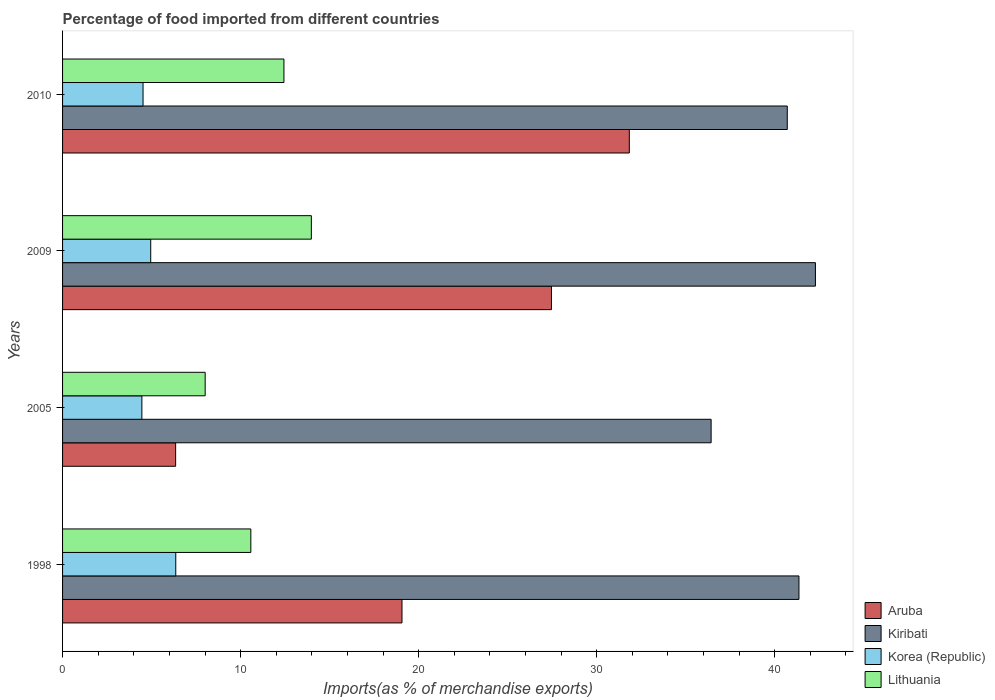How many groups of bars are there?
Keep it short and to the point. 4. Are the number of bars on each tick of the Y-axis equal?
Your response must be concise. Yes. How many bars are there on the 2nd tick from the bottom?
Provide a succinct answer. 4. What is the percentage of imports to different countries in Aruba in 2009?
Ensure brevity in your answer.  27.46. Across all years, what is the maximum percentage of imports to different countries in Aruba?
Ensure brevity in your answer.  31.83. Across all years, what is the minimum percentage of imports to different countries in Aruba?
Provide a short and direct response. 6.35. In which year was the percentage of imports to different countries in Kiribati maximum?
Your answer should be very brief. 2009. What is the total percentage of imports to different countries in Korea (Republic) in the graph?
Your answer should be compact. 20.28. What is the difference between the percentage of imports to different countries in Aruba in 2005 and that in 2010?
Give a very brief answer. -25.48. What is the difference between the percentage of imports to different countries in Lithuania in 2010 and the percentage of imports to different countries in Aruba in 1998?
Offer a terse response. -6.63. What is the average percentage of imports to different countries in Aruba per year?
Your answer should be very brief. 21.18. In the year 2009, what is the difference between the percentage of imports to different countries in Aruba and percentage of imports to different countries in Kiribati?
Your response must be concise. -14.83. In how many years, is the percentage of imports to different countries in Aruba greater than 22 %?
Make the answer very short. 2. What is the ratio of the percentage of imports to different countries in Korea (Republic) in 1998 to that in 2010?
Offer a terse response. 1.41. Is the difference between the percentage of imports to different countries in Aruba in 2005 and 2009 greater than the difference between the percentage of imports to different countries in Kiribati in 2005 and 2009?
Your response must be concise. No. What is the difference between the highest and the second highest percentage of imports to different countries in Korea (Republic)?
Your answer should be very brief. 1.41. What is the difference between the highest and the lowest percentage of imports to different countries in Lithuania?
Provide a succinct answer. 5.96. Is it the case that in every year, the sum of the percentage of imports to different countries in Lithuania and percentage of imports to different countries in Kiribati is greater than the sum of percentage of imports to different countries in Korea (Republic) and percentage of imports to different countries in Aruba?
Give a very brief answer. No. What does the 1st bar from the top in 2010 represents?
Provide a succinct answer. Lithuania. Is it the case that in every year, the sum of the percentage of imports to different countries in Lithuania and percentage of imports to different countries in Korea (Republic) is greater than the percentage of imports to different countries in Aruba?
Make the answer very short. No. Are all the bars in the graph horizontal?
Offer a very short reply. Yes. What is the difference between two consecutive major ticks on the X-axis?
Give a very brief answer. 10. Are the values on the major ticks of X-axis written in scientific E-notation?
Your answer should be very brief. No. What is the title of the graph?
Your response must be concise. Percentage of food imported from different countries. What is the label or title of the X-axis?
Give a very brief answer. Imports(as % of merchandise exports). What is the label or title of the Y-axis?
Your answer should be compact. Years. What is the Imports(as % of merchandise exports) in Aruba in 1998?
Offer a terse response. 19.06. What is the Imports(as % of merchandise exports) in Kiribati in 1998?
Ensure brevity in your answer.  41.36. What is the Imports(as % of merchandise exports) of Korea (Republic) in 1998?
Provide a short and direct response. 6.36. What is the Imports(as % of merchandise exports) of Lithuania in 1998?
Offer a very short reply. 10.57. What is the Imports(as % of merchandise exports) of Aruba in 2005?
Your response must be concise. 6.35. What is the Imports(as % of merchandise exports) in Kiribati in 2005?
Your response must be concise. 36.43. What is the Imports(as % of merchandise exports) of Korea (Republic) in 2005?
Keep it short and to the point. 4.45. What is the Imports(as % of merchandise exports) of Lithuania in 2005?
Give a very brief answer. 8.01. What is the Imports(as % of merchandise exports) of Aruba in 2009?
Your response must be concise. 27.46. What is the Imports(as % of merchandise exports) in Kiribati in 2009?
Keep it short and to the point. 42.29. What is the Imports(as % of merchandise exports) in Korea (Republic) in 2009?
Provide a short and direct response. 4.95. What is the Imports(as % of merchandise exports) in Lithuania in 2009?
Offer a terse response. 13.97. What is the Imports(as % of merchandise exports) in Aruba in 2010?
Ensure brevity in your answer.  31.83. What is the Imports(as % of merchandise exports) of Kiribati in 2010?
Your response must be concise. 40.7. What is the Imports(as % of merchandise exports) of Korea (Republic) in 2010?
Your answer should be compact. 4.52. What is the Imports(as % of merchandise exports) in Lithuania in 2010?
Make the answer very short. 12.43. Across all years, what is the maximum Imports(as % of merchandise exports) in Aruba?
Offer a very short reply. 31.83. Across all years, what is the maximum Imports(as % of merchandise exports) of Kiribati?
Keep it short and to the point. 42.29. Across all years, what is the maximum Imports(as % of merchandise exports) of Korea (Republic)?
Offer a terse response. 6.36. Across all years, what is the maximum Imports(as % of merchandise exports) in Lithuania?
Offer a terse response. 13.97. Across all years, what is the minimum Imports(as % of merchandise exports) of Aruba?
Provide a short and direct response. 6.35. Across all years, what is the minimum Imports(as % of merchandise exports) of Kiribati?
Your answer should be compact. 36.43. Across all years, what is the minimum Imports(as % of merchandise exports) in Korea (Republic)?
Ensure brevity in your answer.  4.45. Across all years, what is the minimum Imports(as % of merchandise exports) of Lithuania?
Give a very brief answer. 8.01. What is the total Imports(as % of merchandise exports) in Aruba in the graph?
Ensure brevity in your answer.  84.71. What is the total Imports(as % of merchandise exports) of Kiribati in the graph?
Make the answer very short. 160.78. What is the total Imports(as % of merchandise exports) of Korea (Republic) in the graph?
Your response must be concise. 20.28. What is the total Imports(as % of merchandise exports) in Lithuania in the graph?
Provide a succinct answer. 44.99. What is the difference between the Imports(as % of merchandise exports) of Aruba in 1998 and that in 2005?
Offer a very short reply. 12.71. What is the difference between the Imports(as % of merchandise exports) in Kiribati in 1998 and that in 2005?
Give a very brief answer. 4.93. What is the difference between the Imports(as % of merchandise exports) in Korea (Republic) in 1998 and that in 2005?
Offer a very short reply. 1.9. What is the difference between the Imports(as % of merchandise exports) of Lithuania in 1998 and that in 2005?
Your answer should be compact. 2.56. What is the difference between the Imports(as % of merchandise exports) in Aruba in 1998 and that in 2009?
Make the answer very short. -8.4. What is the difference between the Imports(as % of merchandise exports) in Kiribati in 1998 and that in 2009?
Ensure brevity in your answer.  -0.93. What is the difference between the Imports(as % of merchandise exports) in Korea (Republic) in 1998 and that in 2009?
Your answer should be very brief. 1.41. What is the difference between the Imports(as % of merchandise exports) in Lithuania in 1998 and that in 2009?
Ensure brevity in your answer.  -3.4. What is the difference between the Imports(as % of merchandise exports) in Aruba in 1998 and that in 2010?
Keep it short and to the point. -12.77. What is the difference between the Imports(as % of merchandise exports) in Kiribati in 1998 and that in 2010?
Provide a short and direct response. 0.66. What is the difference between the Imports(as % of merchandise exports) in Korea (Republic) in 1998 and that in 2010?
Your answer should be compact. 1.84. What is the difference between the Imports(as % of merchandise exports) in Lithuania in 1998 and that in 2010?
Give a very brief answer. -1.86. What is the difference between the Imports(as % of merchandise exports) of Aruba in 2005 and that in 2009?
Keep it short and to the point. -21.11. What is the difference between the Imports(as % of merchandise exports) in Kiribati in 2005 and that in 2009?
Give a very brief answer. -5.86. What is the difference between the Imports(as % of merchandise exports) in Korea (Republic) in 2005 and that in 2009?
Offer a very short reply. -0.5. What is the difference between the Imports(as % of merchandise exports) of Lithuania in 2005 and that in 2009?
Give a very brief answer. -5.96. What is the difference between the Imports(as % of merchandise exports) in Aruba in 2005 and that in 2010?
Give a very brief answer. -25.48. What is the difference between the Imports(as % of merchandise exports) in Kiribati in 2005 and that in 2010?
Offer a terse response. -4.28. What is the difference between the Imports(as % of merchandise exports) in Korea (Republic) in 2005 and that in 2010?
Give a very brief answer. -0.07. What is the difference between the Imports(as % of merchandise exports) in Lithuania in 2005 and that in 2010?
Your response must be concise. -4.42. What is the difference between the Imports(as % of merchandise exports) in Aruba in 2009 and that in 2010?
Give a very brief answer. -4.37. What is the difference between the Imports(as % of merchandise exports) of Kiribati in 2009 and that in 2010?
Give a very brief answer. 1.58. What is the difference between the Imports(as % of merchandise exports) in Korea (Republic) in 2009 and that in 2010?
Give a very brief answer. 0.43. What is the difference between the Imports(as % of merchandise exports) in Lithuania in 2009 and that in 2010?
Offer a terse response. 1.54. What is the difference between the Imports(as % of merchandise exports) in Aruba in 1998 and the Imports(as % of merchandise exports) in Kiribati in 2005?
Ensure brevity in your answer.  -17.36. What is the difference between the Imports(as % of merchandise exports) of Aruba in 1998 and the Imports(as % of merchandise exports) of Korea (Republic) in 2005?
Your answer should be compact. 14.61. What is the difference between the Imports(as % of merchandise exports) of Aruba in 1998 and the Imports(as % of merchandise exports) of Lithuania in 2005?
Ensure brevity in your answer.  11.05. What is the difference between the Imports(as % of merchandise exports) of Kiribati in 1998 and the Imports(as % of merchandise exports) of Korea (Republic) in 2005?
Provide a succinct answer. 36.91. What is the difference between the Imports(as % of merchandise exports) of Kiribati in 1998 and the Imports(as % of merchandise exports) of Lithuania in 2005?
Your answer should be compact. 33.35. What is the difference between the Imports(as % of merchandise exports) of Korea (Republic) in 1998 and the Imports(as % of merchandise exports) of Lithuania in 2005?
Give a very brief answer. -1.65. What is the difference between the Imports(as % of merchandise exports) of Aruba in 1998 and the Imports(as % of merchandise exports) of Kiribati in 2009?
Provide a succinct answer. -23.22. What is the difference between the Imports(as % of merchandise exports) in Aruba in 1998 and the Imports(as % of merchandise exports) in Korea (Republic) in 2009?
Keep it short and to the point. 14.11. What is the difference between the Imports(as % of merchandise exports) of Aruba in 1998 and the Imports(as % of merchandise exports) of Lithuania in 2009?
Keep it short and to the point. 5.09. What is the difference between the Imports(as % of merchandise exports) in Kiribati in 1998 and the Imports(as % of merchandise exports) in Korea (Republic) in 2009?
Offer a very short reply. 36.41. What is the difference between the Imports(as % of merchandise exports) of Kiribati in 1998 and the Imports(as % of merchandise exports) of Lithuania in 2009?
Provide a short and direct response. 27.39. What is the difference between the Imports(as % of merchandise exports) of Korea (Republic) in 1998 and the Imports(as % of merchandise exports) of Lithuania in 2009?
Provide a short and direct response. -7.62. What is the difference between the Imports(as % of merchandise exports) in Aruba in 1998 and the Imports(as % of merchandise exports) in Kiribati in 2010?
Your response must be concise. -21.64. What is the difference between the Imports(as % of merchandise exports) in Aruba in 1998 and the Imports(as % of merchandise exports) in Korea (Republic) in 2010?
Offer a very short reply. 14.54. What is the difference between the Imports(as % of merchandise exports) in Aruba in 1998 and the Imports(as % of merchandise exports) in Lithuania in 2010?
Your response must be concise. 6.63. What is the difference between the Imports(as % of merchandise exports) of Kiribati in 1998 and the Imports(as % of merchandise exports) of Korea (Republic) in 2010?
Provide a short and direct response. 36.84. What is the difference between the Imports(as % of merchandise exports) of Kiribati in 1998 and the Imports(as % of merchandise exports) of Lithuania in 2010?
Provide a succinct answer. 28.93. What is the difference between the Imports(as % of merchandise exports) in Korea (Republic) in 1998 and the Imports(as % of merchandise exports) in Lithuania in 2010?
Keep it short and to the point. -6.08. What is the difference between the Imports(as % of merchandise exports) of Aruba in 2005 and the Imports(as % of merchandise exports) of Kiribati in 2009?
Your answer should be compact. -35.94. What is the difference between the Imports(as % of merchandise exports) in Aruba in 2005 and the Imports(as % of merchandise exports) in Korea (Republic) in 2009?
Give a very brief answer. 1.4. What is the difference between the Imports(as % of merchandise exports) of Aruba in 2005 and the Imports(as % of merchandise exports) of Lithuania in 2009?
Your response must be concise. -7.62. What is the difference between the Imports(as % of merchandise exports) in Kiribati in 2005 and the Imports(as % of merchandise exports) in Korea (Republic) in 2009?
Keep it short and to the point. 31.48. What is the difference between the Imports(as % of merchandise exports) in Kiribati in 2005 and the Imports(as % of merchandise exports) in Lithuania in 2009?
Your answer should be compact. 22.45. What is the difference between the Imports(as % of merchandise exports) in Korea (Republic) in 2005 and the Imports(as % of merchandise exports) in Lithuania in 2009?
Your response must be concise. -9.52. What is the difference between the Imports(as % of merchandise exports) in Aruba in 2005 and the Imports(as % of merchandise exports) in Kiribati in 2010?
Keep it short and to the point. -34.35. What is the difference between the Imports(as % of merchandise exports) of Aruba in 2005 and the Imports(as % of merchandise exports) of Korea (Republic) in 2010?
Your response must be concise. 1.83. What is the difference between the Imports(as % of merchandise exports) in Aruba in 2005 and the Imports(as % of merchandise exports) in Lithuania in 2010?
Offer a terse response. -6.08. What is the difference between the Imports(as % of merchandise exports) in Kiribati in 2005 and the Imports(as % of merchandise exports) in Korea (Republic) in 2010?
Your response must be concise. 31.91. What is the difference between the Imports(as % of merchandise exports) of Kiribati in 2005 and the Imports(as % of merchandise exports) of Lithuania in 2010?
Your response must be concise. 23.99. What is the difference between the Imports(as % of merchandise exports) of Korea (Republic) in 2005 and the Imports(as % of merchandise exports) of Lithuania in 2010?
Provide a short and direct response. -7.98. What is the difference between the Imports(as % of merchandise exports) in Aruba in 2009 and the Imports(as % of merchandise exports) in Kiribati in 2010?
Provide a short and direct response. -13.25. What is the difference between the Imports(as % of merchandise exports) of Aruba in 2009 and the Imports(as % of merchandise exports) of Korea (Republic) in 2010?
Your answer should be very brief. 22.94. What is the difference between the Imports(as % of merchandise exports) of Aruba in 2009 and the Imports(as % of merchandise exports) of Lithuania in 2010?
Offer a terse response. 15.03. What is the difference between the Imports(as % of merchandise exports) of Kiribati in 2009 and the Imports(as % of merchandise exports) of Korea (Republic) in 2010?
Make the answer very short. 37.77. What is the difference between the Imports(as % of merchandise exports) of Kiribati in 2009 and the Imports(as % of merchandise exports) of Lithuania in 2010?
Your response must be concise. 29.85. What is the difference between the Imports(as % of merchandise exports) in Korea (Republic) in 2009 and the Imports(as % of merchandise exports) in Lithuania in 2010?
Provide a short and direct response. -7.48. What is the average Imports(as % of merchandise exports) of Aruba per year?
Ensure brevity in your answer.  21.18. What is the average Imports(as % of merchandise exports) in Kiribati per year?
Ensure brevity in your answer.  40.19. What is the average Imports(as % of merchandise exports) of Korea (Republic) per year?
Your answer should be very brief. 5.07. What is the average Imports(as % of merchandise exports) of Lithuania per year?
Give a very brief answer. 11.25. In the year 1998, what is the difference between the Imports(as % of merchandise exports) in Aruba and Imports(as % of merchandise exports) in Kiribati?
Give a very brief answer. -22.3. In the year 1998, what is the difference between the Imports(as % of merchandise exports) in Aruba and Imports(as % of merchandise exports) in Korea (Republic)?
Ensure brevity in your answer.  12.71. In the year 1998, what is the difference between the Imports(as % of merchandise exports) in Aruba and Imports(as % of merchandise exports) in Lithuania?
Provide a short and direct response. 8.49. In the year 1998, what is the difference between the Imports(as % of merchandise exports) of Kiribati and Imports(as % of merchandise exports) of Korea (Republic)?
Make the answer very short. 35. In the year 1998, what is the difference between the Imports(as % of merchandise exports) of Kiribati and Imports(as % of merchandise exports) of Lithuania?
Provide a short and direct response. 30.79. In the year 1998, what is the difference between the Imports(as % of merchandise exports) in Korea (Republic) and Imports(as % of merchandise exports) in Lithuania?
Give a very brief answer. -4.22. In the year 2005, what is the difference between the Imports(as % of merchandise exports) of Aruba and Imports(as % of merchandise exports) of Kiribati?
Offer a terse response. -30.08. In the year 2005, what is the difference between the Imports(as % of merchandise exports) of Aruba and Imports(as % of merchandise exports) of Korea (Republic)?
Keep it short and to the point. 1.9. In the year 2005, what is the difference between the Imports(as % of merchandise exports) in Aruba and Imports(as % of merchandise exports) in Lithuania?
Ensure brevity in your answer.  -1.66. In the year 2005, what is the difference between the Imports(as % of merchandise exports) in Kiribati and Imports(as % of merchandise exports) in Korea (Republic)?
Offer a very short reply. 31.97. In the year 2005, what is the difference between the Imports(as % of merchandise exports) in Kiribati and Imports(as % of merchandise exports) in Lithuania?
Give a very brief answer. 28.42. In the year 2005, what is the difference between the Imports(as % of merchandise exports) in Korea (Republic) and Imports(as % of merchandise exports) in Lithuania?
Your answer should be compact. -3.56. In the year 2009, what is the difference between the Imports(as % of merchandise exports) in Aruba and Imports(as % of merchandise exports) in Kiribati?
Your answer should be compact. -14.83. In the year 2009, what is the difference between the Imports(as % of merchandise exports) of Aruba and Imports(as % of merchandise exports) of Korea (Republic)?
Offer a very short reply. 22.51. In the year 2009, what is the difference between the Imports(as % of merchandise exports) of Aruba and Imports(as % of merchandise exports) of Lithuania?
Offer a terse response. 13.49. In the year 2009, what is the difference between the Imports(as % of merchandise exports) in Kiribati and Imports(as % of merchandise exports) in Korea (Republic)?
Your response must be concise. 37.34. In the year 2009, what is the difference between the Imports(as % of merchandise exports) of Kiribati and Imports(as % of merchandise exports) of Lithuania?
Your response must be concise. 28.31. In the year 2009, what is the difference between the Imports(as % of merchandise exports) of Korea (Republic) and Imports(as % of merchandise exports) of Lithuania?
Offer a very short reply. -9.02. In the year 2010, what is the difference between the Imports(as % of merchandise exports) of Aruba and Imports(as % of merchandise exports) of Kiribati?
Make the answer very short. -8.87. In the year 2010, what is the difference between the Imports(as % of merchandise exports) of Aruba and Imports(as % of merchandise exports) of Korea (Republic)?
Offer a terse response. 27.31. In the year 2010, what is the difference between the Imports(as % of merchandise exports) of Aruba and Imports(as % of merchandise exports) of Lithuania?
Your response must be concise. 19.4. In the year 2010, what is the difference between the Imports(as % of merchandise exports) of Kiribati and Imports(as % of merchandise exports) of Korea (Republic)?
Provide a succinct answer. 36.18. In the year 2010, what is the difference between the Imports(as % of merchandise exports) of Kiribati and Imports(as % of merchandise exports) of Lithuania?
Offer a very short reply. 28.27. In the year 2010, what is the difference between the Imports(as % of merchandise exports) in Korea (Republic) and Imports(as % of merchandise exports) in Lithuania?
Keep it short and to the point. -7.91. What is the ratio of the Imports(as % of merchandise exports) of Aruba in 1998 to that in 2005?
Your response must be concise. 3. What is the ratio of the Imports(as % of merchandise exports) of Kiribati in 1998 to that in 2005?
Your answer should be compact. 1.14. What is the ratio of the Imports(as % of merchandise exports) of Korea (Republic) in 1998 to that in 2005?
Keep it short and to the point. 1.43. What is the ratio of the Imports(as % of merchandise exports) of Lithuania in 1998 to that in 2005?
Ensure brevity in your answer.  1.32. What is the ratio of the Imports(as % of merchandise exports) in Aruba in 1998 to that in 2009?
Your answer should be very brief. 0.69. What is the ratio of the Imports(as % of merchandise exports) in Kiribati in 1998 to that in 2009?
Provide a succinct answer. 0.98. What is the ratio of the Imports(as % of merchandise exports) of Korea (Republic) in 1998 to that in 2009?
Keep it short and to the point. 1.28. What is the ratio of the Imports(as % of merchandise exports) of Lithuania in 1998 to that in 2009?
Make the answer very short. 0.76. What is the ratio of the Imports(as % of merchandise exports) of Aruba in 1998 to that in 2010?
Your response must be concise. 0.6. What is the ratio of the Imports(as % of merchandise exports) in Kiribati in 1998 to that in 2010?
Your response must be concise. 1.02. What is the ratio of the Imports(as % of merchandise exports) in Korea (Republic) in 1998 to that in 2010?
Your response must be concise. 1.41. What is the ratio of the Imports(as % of merchandise exports) of Lithuania in 1998 to that in 2010?
Keep it short and to the point. 0.85. What is the ratio of the Imports(as % of merchandise exports) of Aruba in 2005 to that in 2009?
Your answer should be very brief. 0.23. What is the ratio of the Imports(as % of merchandise exports) of Kiribati in 2005 to that in 2009?
Offer a very short reply. 0.86. What is the ratio of the Imports(as % of merchandise exports) in Korea (Republic) in 2005 to that in 2009?
Keep it short and to the point. 0.9. What is the ratio of the Imports(as % of merchandise exports) of Lithuania in 2005 to that in 2009?
Provide a short and direct response. 0.57. What is the ratio of the Imports(as % of merchandise exports) in Aruba in 2005 to that in 2010?
Keep it short and to the point. 0.2. What is the ratio of the Imports(as % of merchandise exports) in Kiribati in 2005 to that in 2010?
Provide a short and direct response. 0.89. What is the ratio of the Imports(as % of merchandise exports) in Korea (Republic) in 2005 to that in 2010?
Provide a succinct answer. 0.99. What is the ratio of the Imports(as % of merchandise exports) of Lithuania in 2005 to that in 2010?
Your answer should be compact. 0.64. What is the ratio of the Imports(as % of merchandise exports) in Aruba in 2009 to that in 2010?
Ensure brevity in your answer.  0.86. What is the ratio of the Imports(as % of merchandise exports) in Kiribati in 2009 to that in 2010?
Offer a very short reply. 1.04. What is the ratio of the Imports(as % of merchandise exports) of Korea (Republic) in 2009 to that in 2010?
Your answer should be very brief. 1.1. What is the ratio of the Imports(as % of merchandise exports) in Lithuania in 2009 to that in 2010?
Offer a very short reply. 1.12. What is the difference between the highest and the second highest Imports(as % of merchandise exports) of Aruba?
Provide a succinct answer. 4.37. What is the difference between the highest and the second highest Imports(as % of merchandise exports) of Kiribati?
Offer a very short reply. 0.93. What is the difference between the highest and the second highest Imports(as % of merchandise exports) in Korea (Republic)?
Provide a short and direct response. 1.41. What is the difference between the highest and the second highest Imports(as % of merchandise exports) of Lithuania?
Ensure brevity in your answer.  1.54. What is the difference between the highest and the lowest Imports(as % of merchandise exports) of Aruba?
Ensure brevity in your answer.  25.48. What is the difference between the highest and the lowest Imports(as % of merchandise exports) in Kiribati?
Offer a very short reply. 5.86. What is the difference between the highest and the lowest Imports(as % of merchandise exports) in Korea (Republic)?
Give a very brief answer. 1.9. What is the difference between the highest and the lowest Imports(as % of merchandise exports) in Lithuania?
Provide a succinct answer. 5.96. 